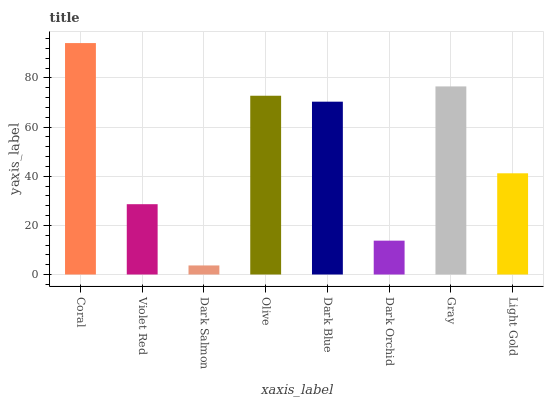Is Dark Salmon the minimum?
Answer yes or no. Yes. Is Coral the maximum?
Answer yes or no. Yes. Is Violet Red the minimum?
Answer yes or no. No. Is Violet Red the maximum?
Answer yes or no. No. Is Coral greater than Violet Red?
Answer yes or no. Yes. Is Violet Red less than Coral?
Answer yes or no. Yes. Is Violet Red greater than Coral?
Answer yes or no. No. Is Coral less than Violet Red?
Answer yes or no. No. Is Dark Blue the high median?
Answer yes or no. Yes. Is Light Gold the low median?
Answer yes or no. Yes. Is Coral the high median?
Answer yes or no. No. Is Coral the low median?
Answer yes or no. No. 